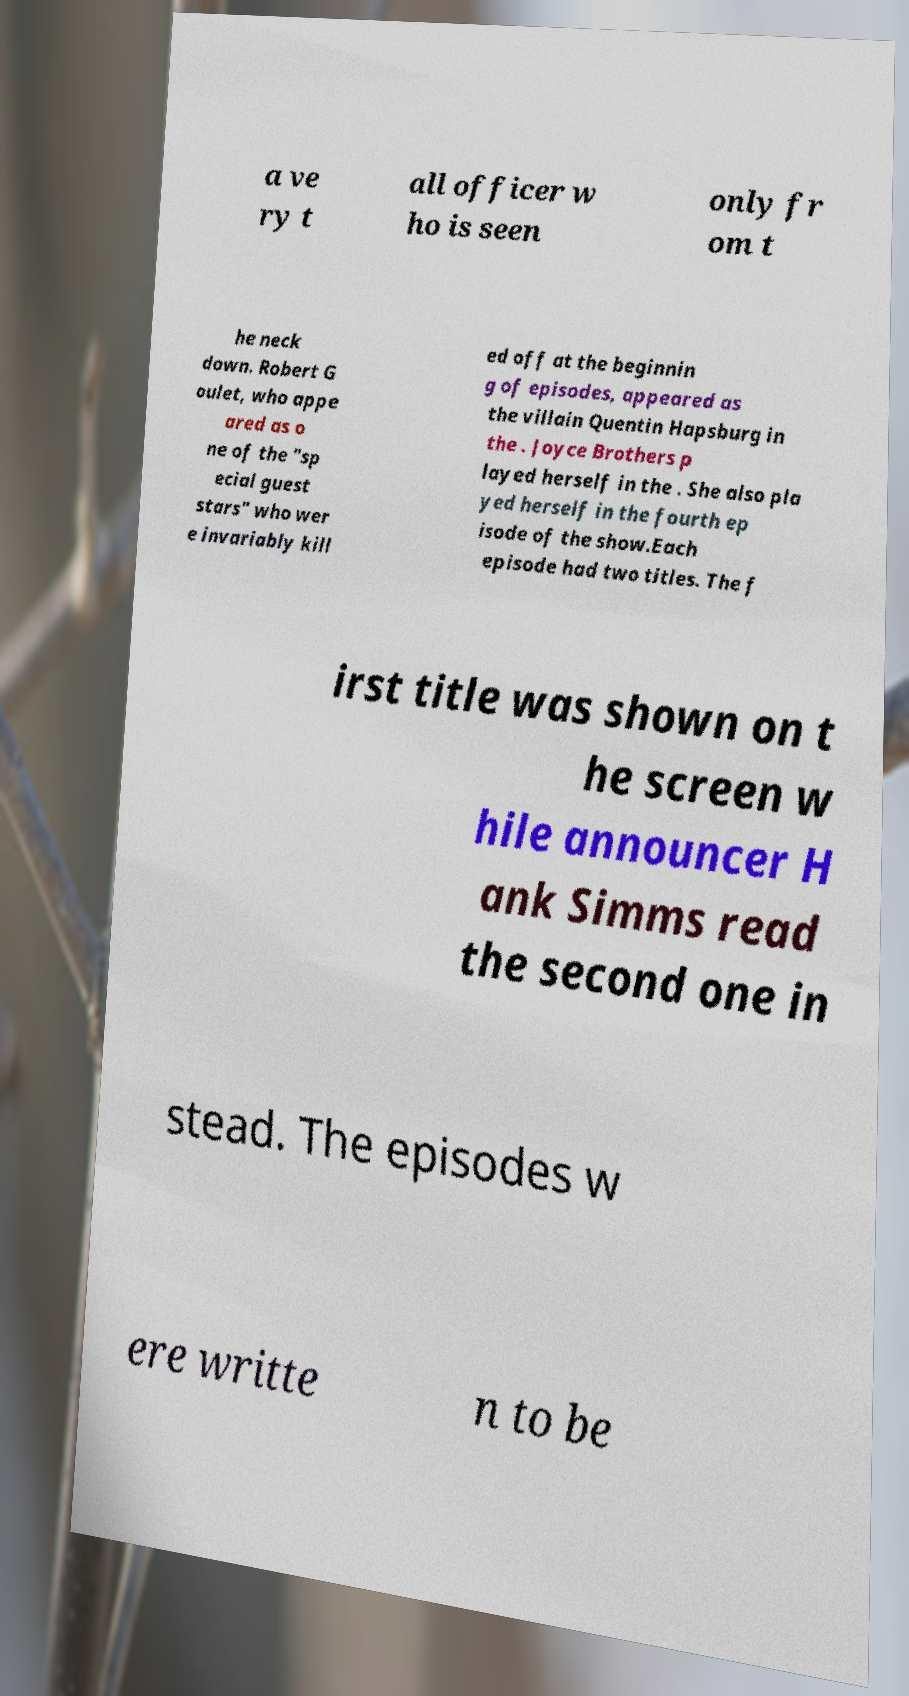Could you assist in decoding the text presented in this image and type it out clearly? a ve ry t all officer w ho is seen only fr om t he neck down. Robert G oulet, who appe ared as o ne of the "sp ecial guest stars" who wer e invariably kill ed off at the beginnin g of episodes, appeared as the villain Quentin Hapsburg in the . Joyce Brothers p layed herself in the . She also pla yed herself in the fourth ep isode of the show.Each episode had two titles. The f irst title was shown on t he screen w hile announcer H ank Simms read the second one in stead. The episodes w ere writte n to be 